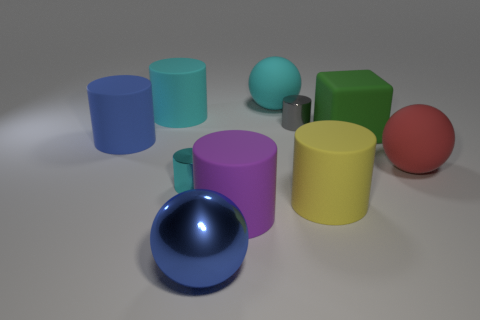Subtract all yellow cylinders. How many cylinders are left? 5 Subtract all cylinders. How many objects are left? 4 Subtract 3 cylinders. How many cylinders are left? 3 Subtract all red blocks. Subtract all red cylinders. How many blocks are left? 1 Subtract all brown cylinders. How many cyan blocks are left? 0 Subtract all large green rubber objects. Subtract all large green rubber objects. How many objects are left? 8 Add 6 cyan matte things. How many cyan matte things are left? 8 Add 5 purple rubber objects. How many purple rubber objects exist? 6 Subtract all red balls. How many balls are left? 2 Subtract 1 cyan spheres. How many objects are left? 9 